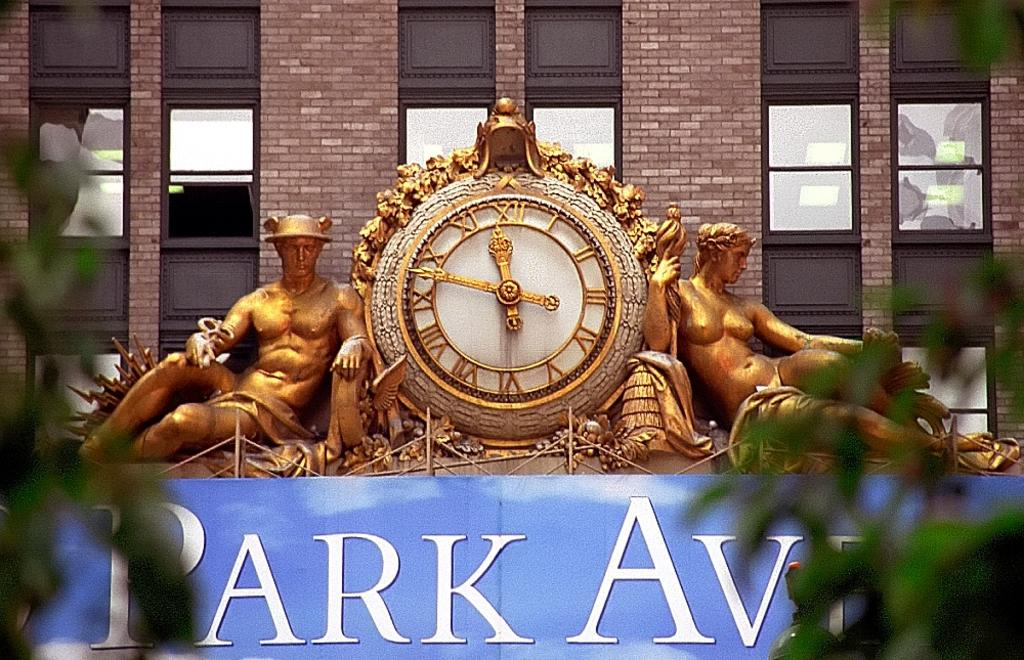<image>
Share a concise interpretation of the image provided. A Park Ave sign with two bronze statues and a clock. 